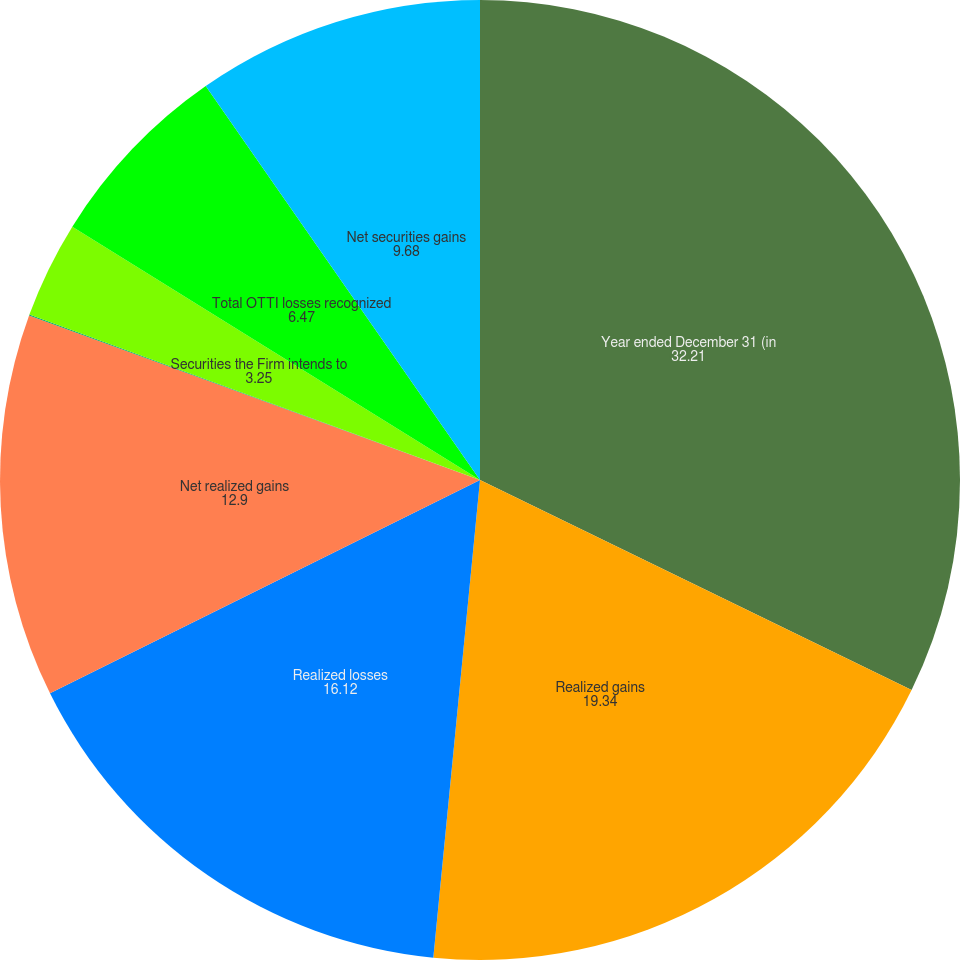<chart> <loc_0><loc_0><loc_500><loc_500><pie_chart><fcel>Year ended December 31 (in<fcel>Realized gains<fcel>Realized losses<fcel>Net realized gains<fcel>Credit-related<fcel>Securities the Firm intends to<fcel>Total OTTI losses recognized<fcel>Net securities gains<nl><fcel>32.21%<fcel>19.34%<fcel>16.12%<fcel>12.9%<fcel>0.03%<fcel>3.25%<fcel>6.47%<fcel>9.68%<nl></chart> 